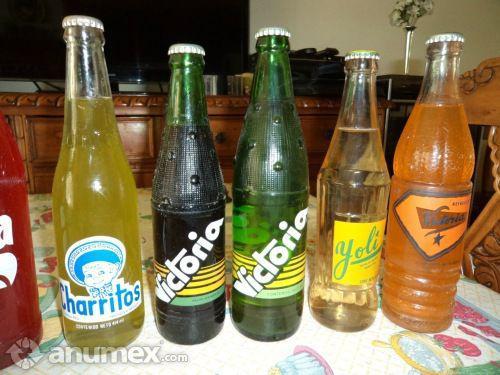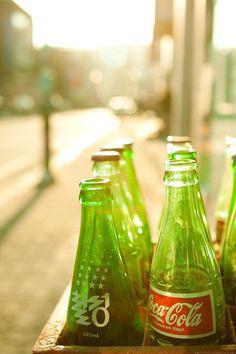The first image is the image on the left, the second image is the image on the right. For the images displayed, is the sentence "In one image the bottles are made of glass and the other has plastic bottles" factually correct? Answer yes or no. No. The first image is the image on the left, the second image is the image on the right. Considering the images on both sides, is "The right image includes at least three upright bottles with multicolored candies on the surface next to them." valid? Answer yes or no. No. 